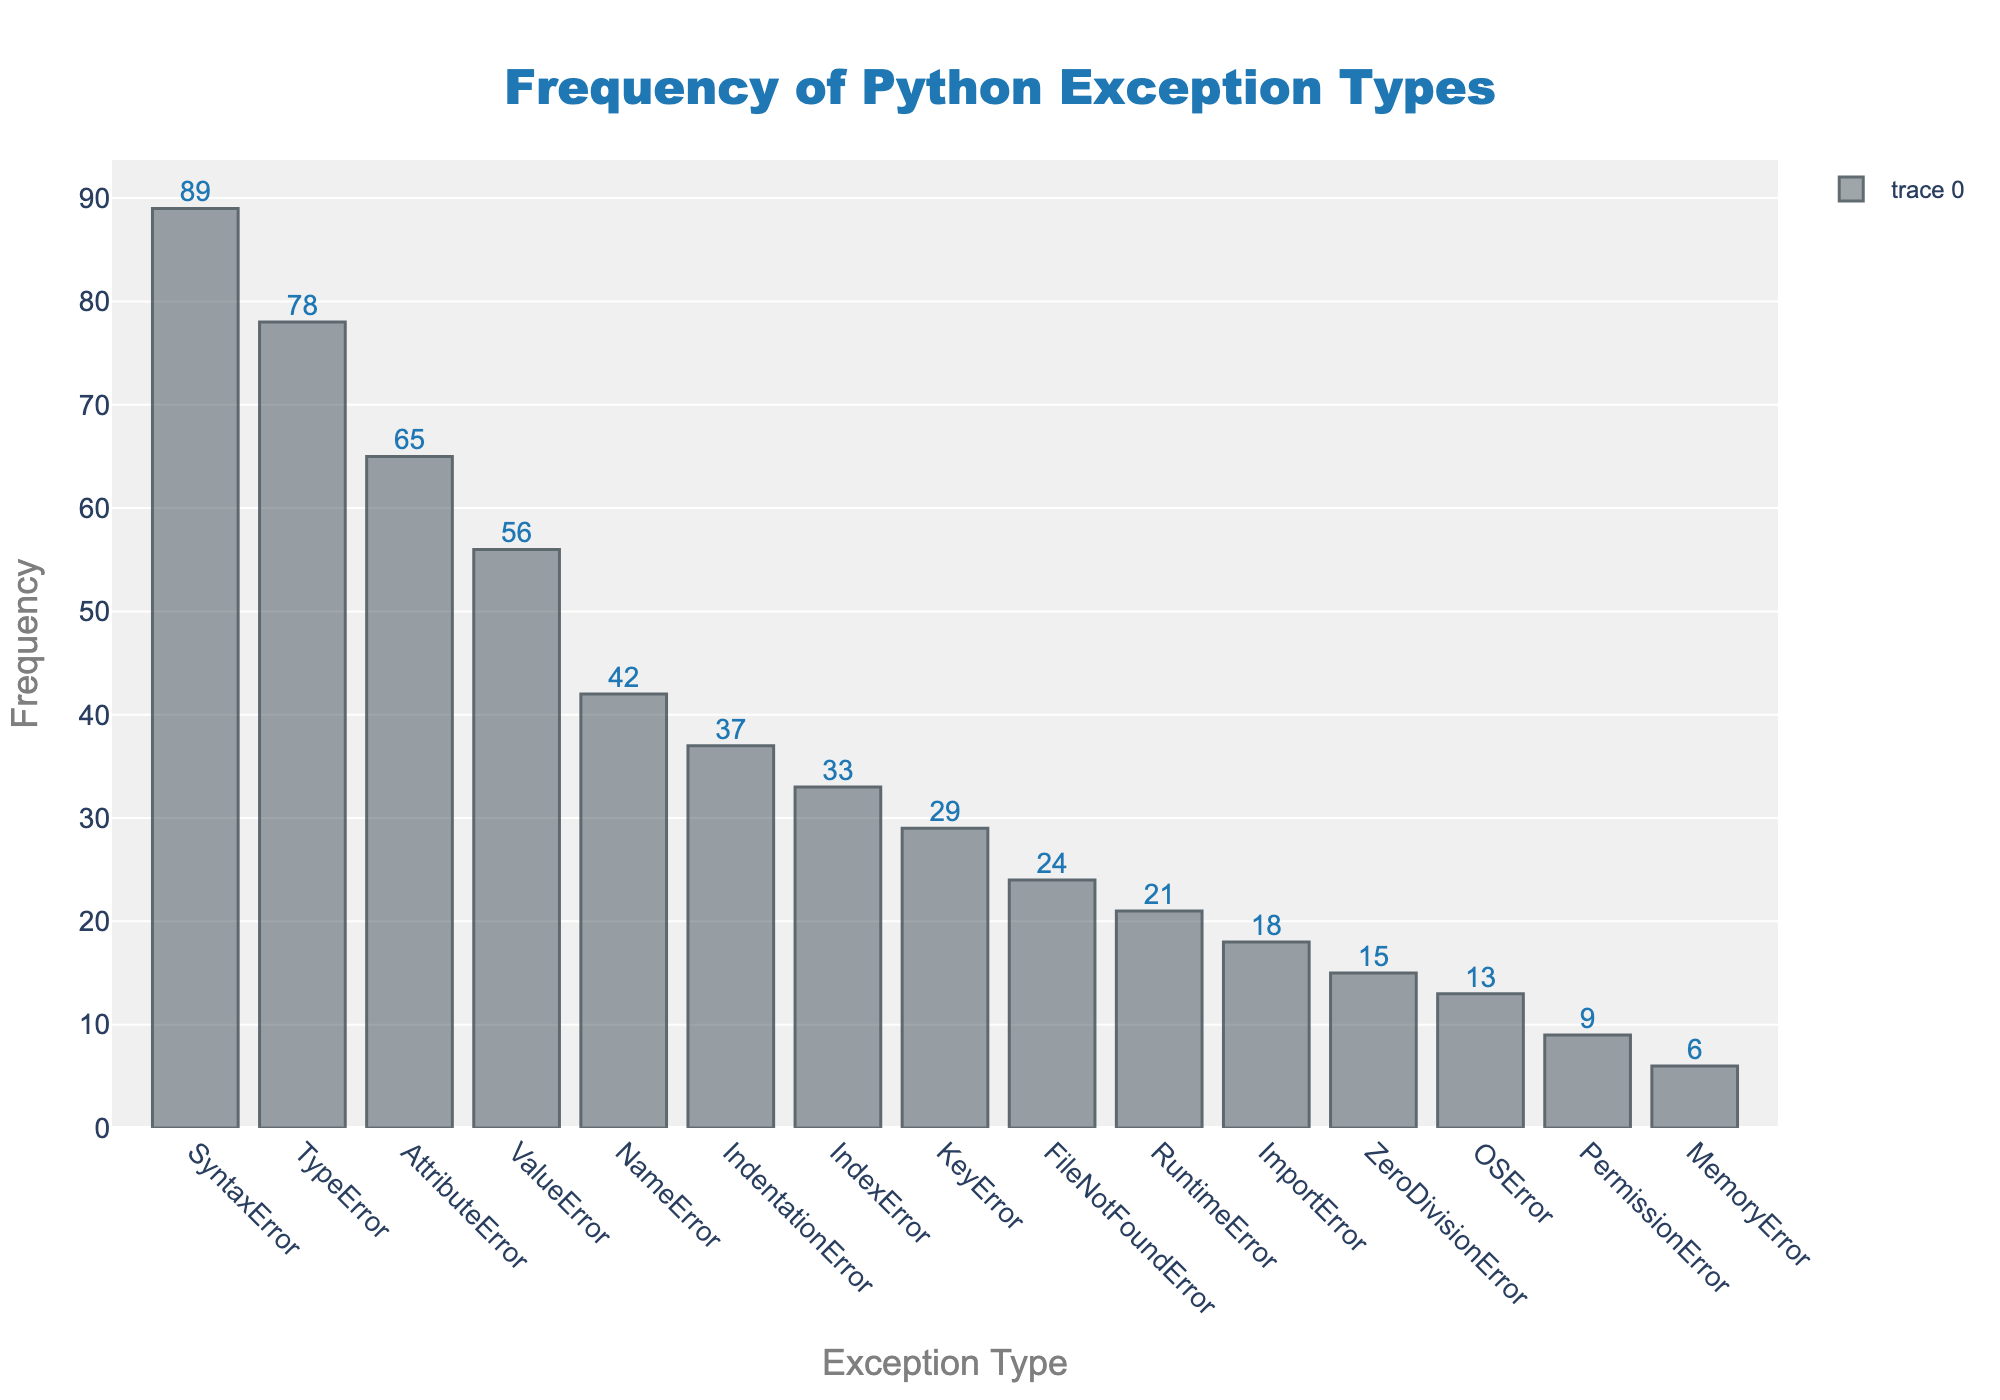What is the most frequent Python exception type? The most frequent Python exception type can be identified by looking at the tallest bar in the histogram. The exception type with the highest bar is 'SyntaxError'.
Answer: SyntaxError Which Python exception type has the lowest frequency? The lowest frequency is represented by the shortest bar in the histogram. The exception type with the shortest bar is 'MemoryError'.
Answer: MemoryError How many exception types have a frequency greater than 50? Count the number of bars with heights higher than 50. The exception types with frequencies greater than 50 are 'TypeError', 'SyntaxError', 'AttributeError', and 'ValueError', making a total of 4.
Answer: 4 What is the total frequency of 'TypeError' and 'ValueError'? Add the frequencies of 'TypeError' (78) and 'ValueError' (56). The total is 78 + 56.
Answer: 134 Which exception types have a frequency between 20 and 40? Identify the bars whose heights lie between 20 and 40. These bars correspond to 'IndexError', 'IndentationError', 'FileNotFoundError', 'RuntimeError', 'ImportError', and 'OSError'.
Answer: IndexError, IndentationError, FileNotFoundError, RuntimeError, ImportError, and OSError Is 'ZeroDivisionError' more frequent than 'OSError'? Compare the heights of the 'ZeroDivisionError' and 'OSError' bars. The frequency of 'ZeroDivisionError' (15) is higher than 'OSError' (13).
Answer: Yes What is the average frequency of all listed Python exception types? Sum all frequencies and divide by the number of exceptions: (42 + 78 + 56 + 33 + 29 + 65 + 18 + 89 + 37 + 24 + 15 + 9 + 21 + 13 + 6) / 15 = 48.
Answer: 48 Which Python exception type has a frequency closest to the average frequency? First, calculate the average frequency: 48. Then, find the exception type with the frequency closest to 48. 'NameError' has a frequency of 42, which is the closest to 48.
Answer: NameError 